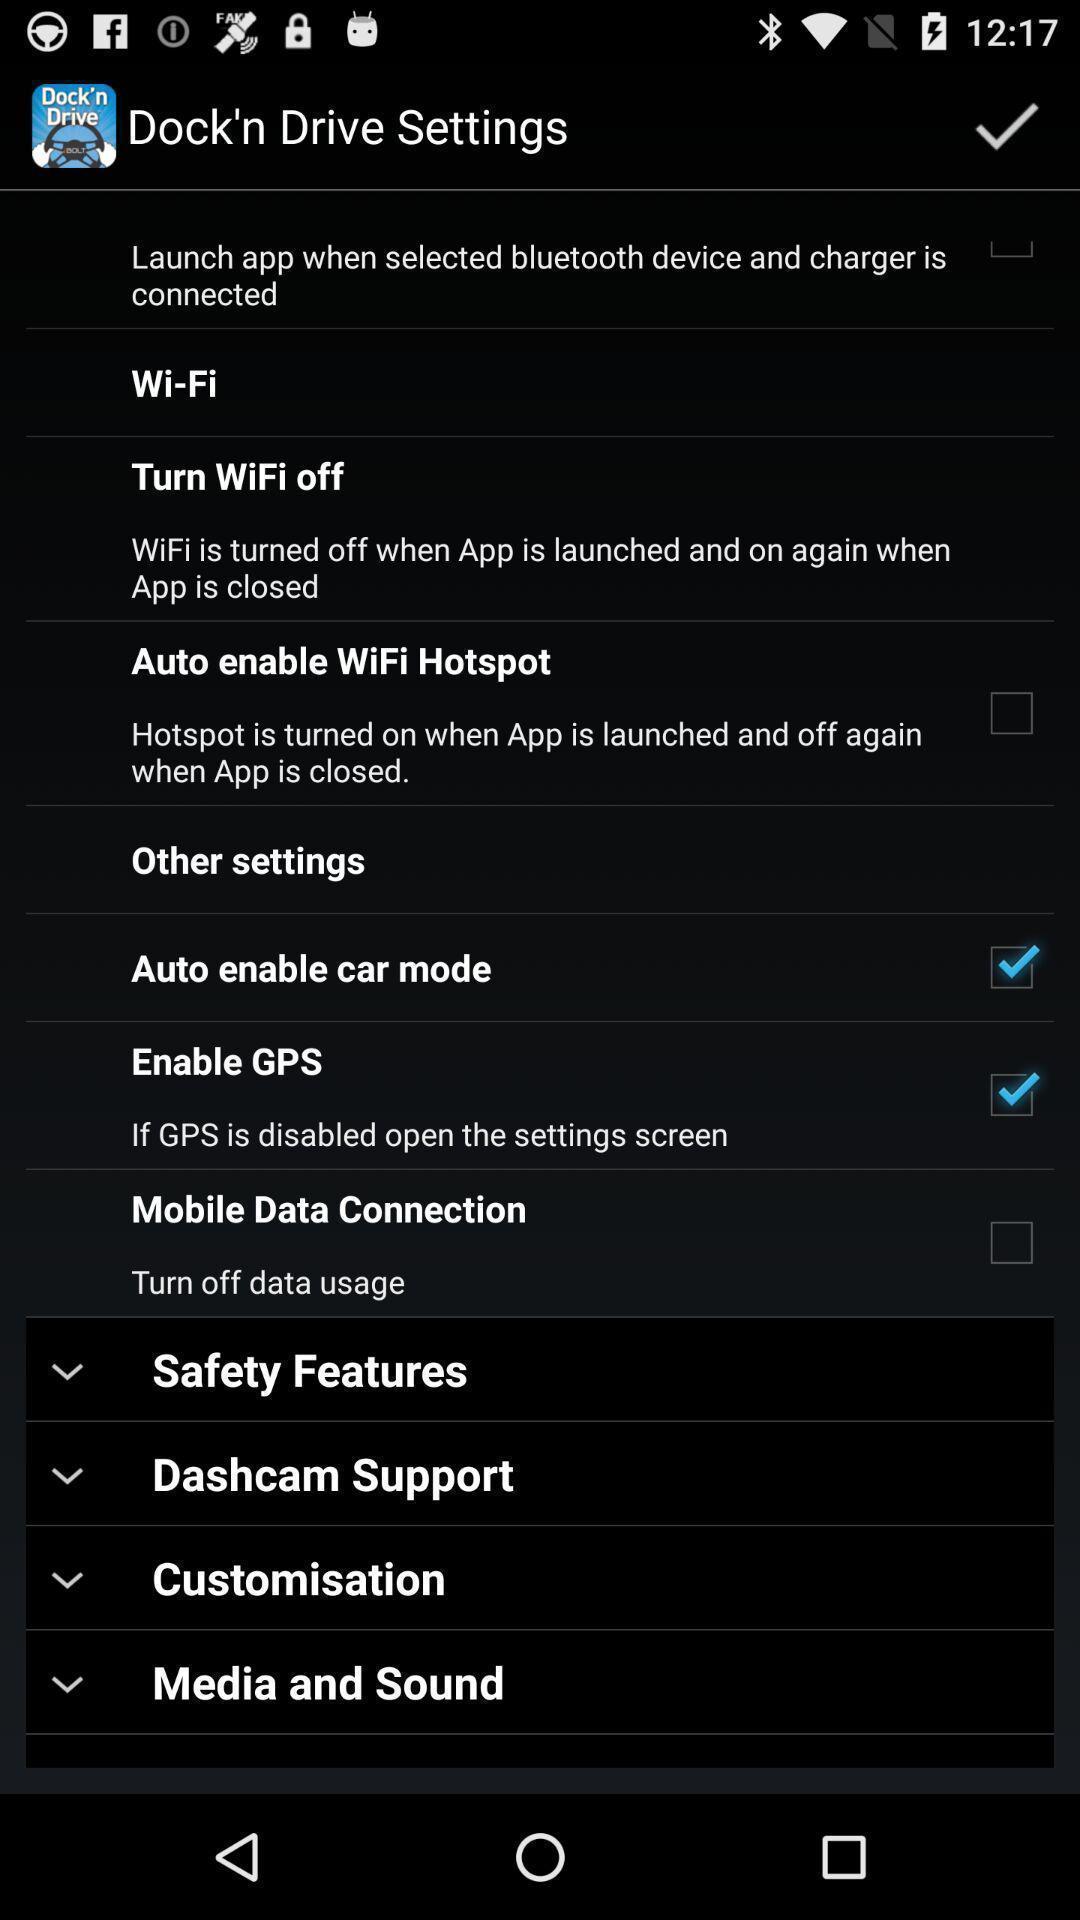Summarize the information in this screenshot. Settings page with various options. 